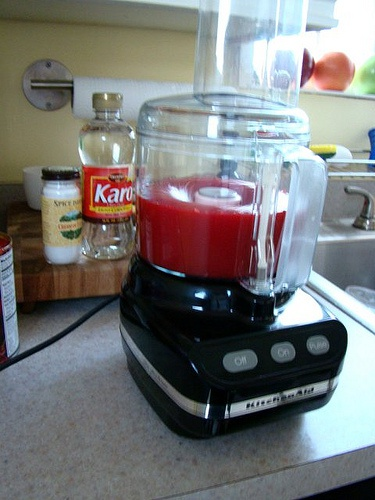Describe the objects in this image and their specific colors. I can see bottle in darkgreen, gray, darkgray, and brown tones, bottle in darkgreen, tan, darkgray, gray, and black tones, sink in darkgreen, gray, and darkgray tones, apple in darkgreen, salmon, and lightpink tones, and bowl in darkgreen, gray, and black tones in this image. 